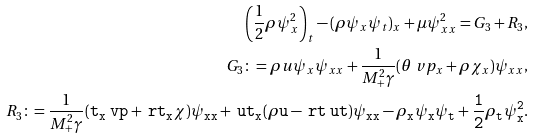<formula> <loc_0><loc_0><loc_500><loc_500>\left ( \frac { 1 } { 2 } \rho \psi _ { x } ^ { 2 } \right ) _ { t } - ( \rho \psi _ { x } \psi _ { t } ) _ { x } + \mu \psi _ { x x } ^ { 2 } = G _ { 3 } + R _ { 3 } , \\ G _ { 3 } \colon = \rho u \psi _ { x } \psi _ { x x } + \frac { 1 } { M _ { + } ^ { 2 } \gamma } ( \theta \ v p _ { x } + \rho \chi _ { x } ) \psi _ { x x } , \\ R _ { 3 } \colon = \frac { 1 } { M _ { + } ^ { 2 } \gamma } ( \tt t _ { x } \ v p + \ r t _ { x } \chi ) \psi _ { x x } + \ u t _ { x } ( \rho u - \ r t \ u t ) \psi _ { x x } - \rho _ { x } \psi _ { x } \psi _ { t } + \frac { 1 } { 2 } \rho _ { t } \psi _ { x } ^ { 2 } .</formula> 